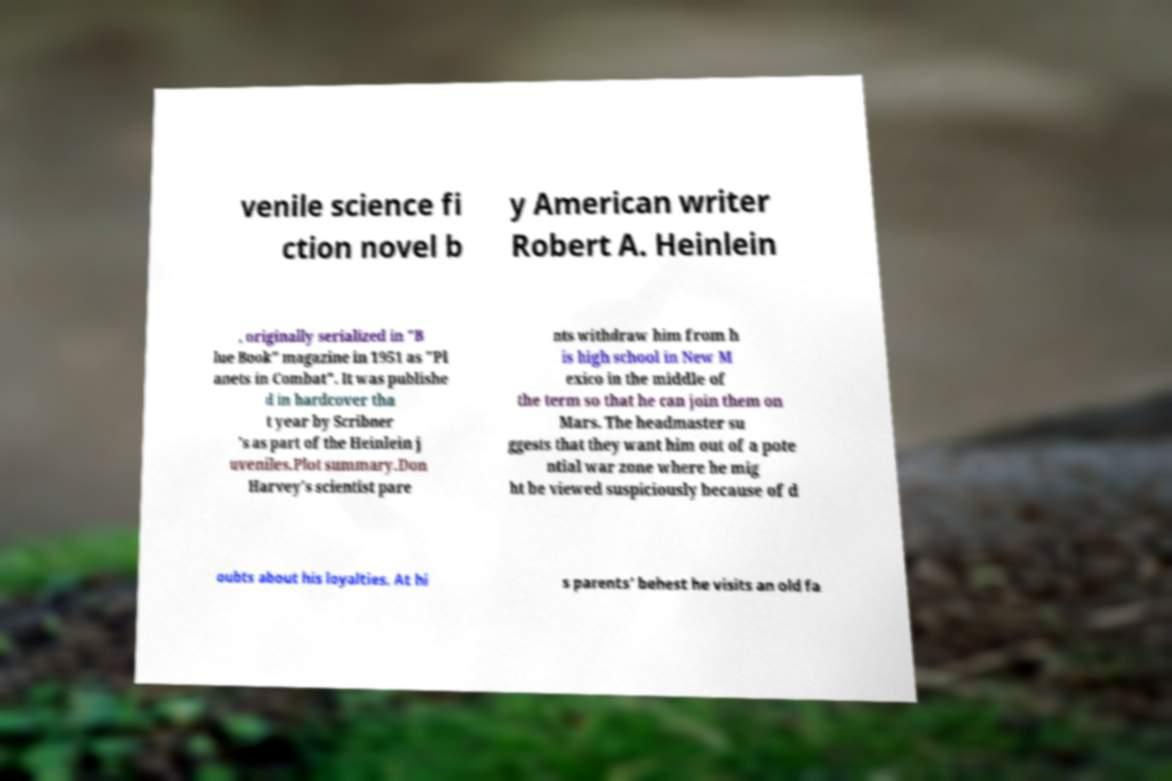I need the written content from this picture converted into text. Can you do that? venile science fi ction novel b y American writer Robert A. Heinlein , originally serialized in "B lue Book" magazine in 1951 as "Pl anets in Combat". It was publishe d in hardcover tha t year by Scribner 's as part of the Heinlein j uveniles.Plot summary.Don Harvey's scientist pare nts withdraw him from h is high school in New M exico in the middle of the term so that he can join them on Mars. The headmaster su ggests that they want him out of a pote ntial war zone where he mig ht be viewed suspiciously because of d oubts about his loyalties. At hi s parents' behest he visits an old fa 